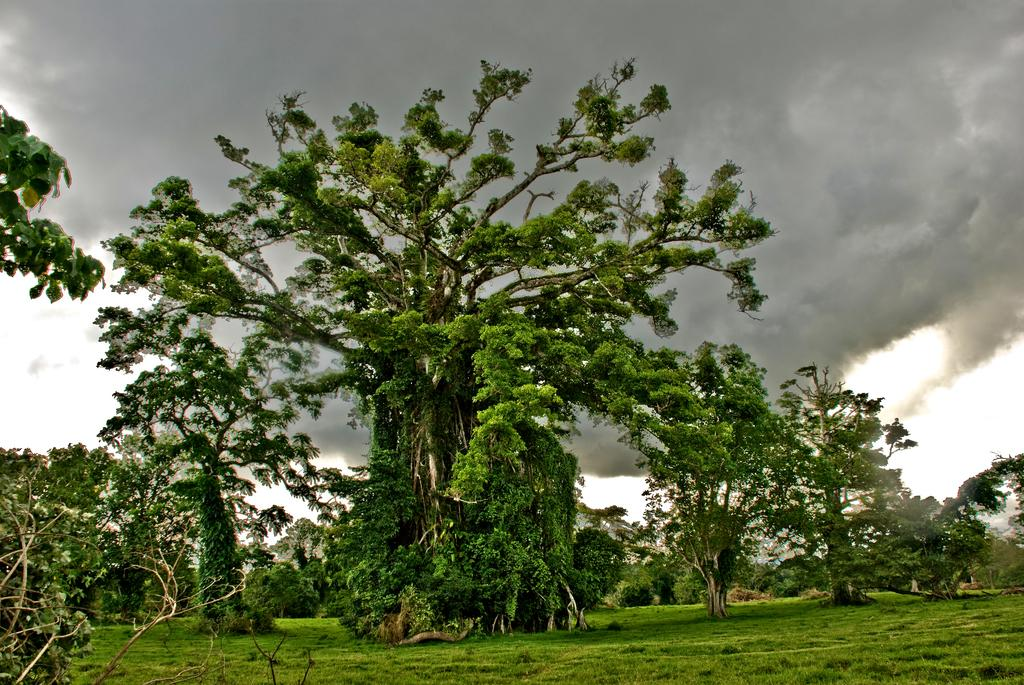What type of vegetation is at the bottom of the image? There is grass at the bottom of the image. What can be seen in the background of the image? There are trees in the background of the image. What is visible in the sky in the image? Clouds are visible in the sky in the image. What type of collar can be seen on the ghost in the image? There is no ghost present in the image, so there is no collar to observe. What nation is represented by the flag in the image? There is no flag present in the image, so it is not possible to determine which nation is represented. 